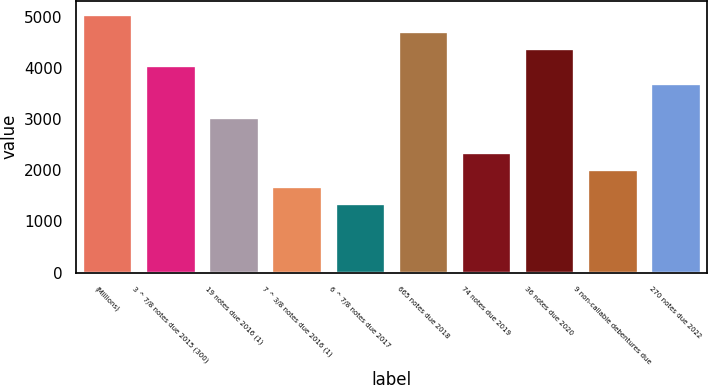<chart> <loc_0><loc_0><loc_500><loc_500><bar_chart><fcel>(Millions)<fcel>3 ^ 7/8 notes due 2015 (300)<fcel>19 notes due 2016 (1)<fcel>7 ^ 3/8 notes due 2016 (1)<fcel>6 ^ 7/8 notes due 2017<fcel>665 notes due 2018<fcel>74 notes due 2019<fcel>36 notes due 2020<fcel>9 non-callable debentures due<fcel>270 notes due 2022<nl><fcel>5062<fcel>4050.4<fcel>3038.8<fcel>1690<fcel>1352.8<fcel>4724.8<fcel>2364.4<fcel>4387.6<fcel>2027.2<fcel>3713.2<nl></chart> 